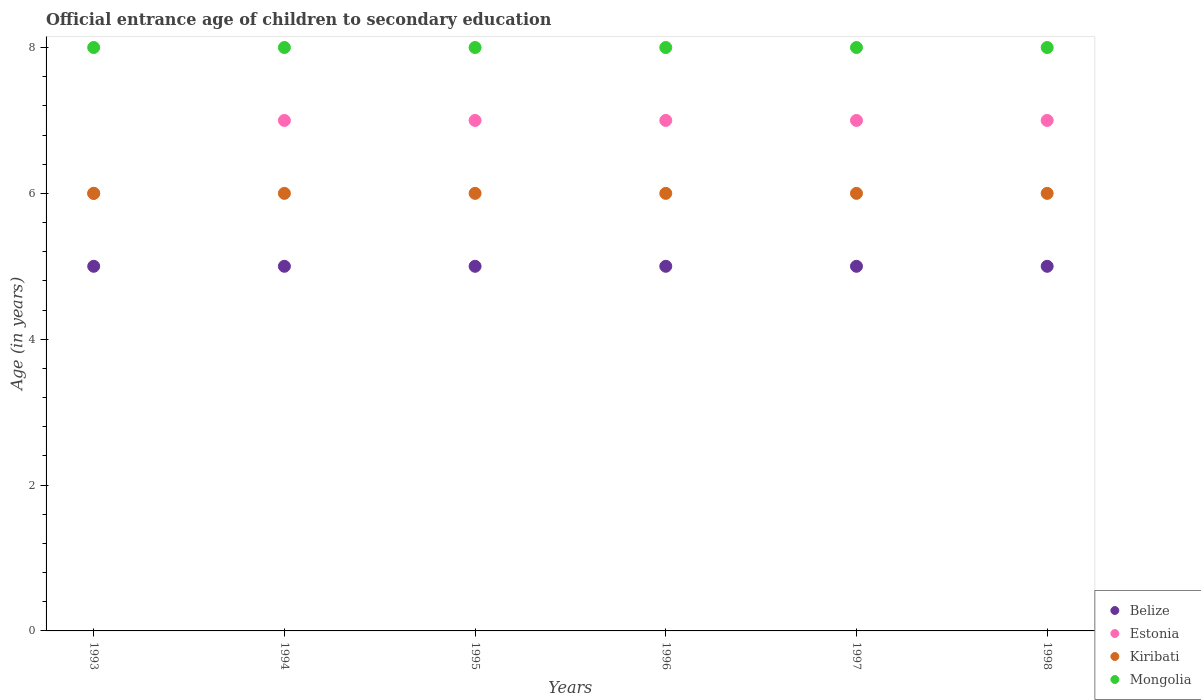Is the number of dotlines equal to the number of legend labels?
Your response must be concise. Yes. What is the secondary school starting age of children in Kiribati in 1997?
Your response must be concise. 6. Across all years, what is the maximum secondary school starting age of children in Belize?
Your answer should be compact. 5. Across all years, what is the minimum secondary school starting age of children in Belize?
Provide a succinct answer. 5. What is the total secondary school starting age of children in Belize in the graph?
Provide a short and direct response. 30. What is the difference between the secondary school starting age of children in Belize in 1996 and that in 1998?
Give a very brief answer. 0. What is the difference between the secondary school starting age of children in Estonia in 1993 and the secondary school starting age of children in Mongolia in 1997?
Ensure brevity in your answer.  -2. What is the average secondary school starting age of children in Estonia per year?
Give a very brief answer. 6.83. In the year 1994, what is the difference between the secondary school starting age of children in Estonia and secondary school starting age of children in Mongolia?
Offer a very short reply. -1. In how many years, is the secondary school starting age of children in Belize greater than 2.8 years?
Give a very brief answer. 6. What is the ratio of the secondary school starting age of children in Estonia in 1993 to that in 1996?
Give a very brief answer. 0.86. What is the difference between the highest and the second highest secondary school starting age of children in Estonia?
Your response must be concise. 0. What is the difference between the highest and the lowest secondary school starting age of children in Mongolia?
Offer a very short reply. 0. Is it the case that in every year, the sum of the secondary school starting age of children in Estonia and secondary school starting age of children in Mongolia  is greater than the secondary school starting age of children in Kiribati?
Ensure brevity in your answer.  Yes. Does the secondary school starting age of children in Mongolia monotonically increase over the years?
Your answer should be very brief. No. Is the secondary school starting age of children in Kiribati strictly less than the secondary school starting age of children in Estonia over the years?
Give a very brief answer. No. How many dotlines are there?
Offer a very short reply. 4. Does the graph contain any zero values?
Your answer should be compact. No. Where does the legend appear in the graph?
Provide a short and direct response. Bottom right. What is the title of the graph?
Your answer should be compact. Official entrance age of children to secondary education. Does "Italy" appear as one of the legend labels in the graph?
Give a very brief answer. No. What is the label or title of the Y-axis?
Make the answer very short. Age (in years). What is the Age (in years) of Belize in 1993?
Make the answer very short. 5. What is the Age (in years) in Belize in 1994?
Keep it short and to the point. 5. What is the Age (in years) of Kiribati in 1994?
Ensure brevity in your answer.  6. What is the Age (in years) in Mongolia in 1995?
Offer a very short reply. 8. What is the Age (in years) of Kiribati in 1996?
Offer a terse response. 6. What is the Age (in years) in Belize in 1997?
Offer a terse response. 5. What is the Age (in years) in Estonia in 1997?
Give a very brief answer. 7. What is the Age (in years) of Belize in 1998?
Your answer should be very brief. 5. Across all years, what is the maximum Age (in years) of Belize?
Provide a succinct answer. 5. Across all years, what is the maximum Age (in years) in Kiribati?
Offer a terse response. 6. Across all years, what is the maximum Age (in years) of Mongolia?
Offer a very short reply. 8. Across all years, what is the minimum Age (in years) of Estonia?
Provide a short and direct response. 6. What is the total Age (in years) in Kiribati in the graph?
Offer a terse response. 36. What is the difference between the Age (in years) of Kiribati in 1993 and that in 1994?
Provide a succinct answer. 0. What is the difference between the Age (in years) of Belize in 1993 and that in 1995?
Give a very brief answer. 0. What is the difference between the Age (in years) in Belize in 1993 and that in 1996?
Provide a short and direct response. 0. What is the difference between the Age (in years) of Kiribati in 1993 and that in 1996?
Keep it short and to the point. 0. What is the difference between the Age (in years) of Belize in 1993 and that in 1997?
Make the answer very short. 0. What is the difference between the Age (in years) of Kiribati in 1993 and that in 1997?
Provide a succinct answer. 0. What is the difference between the Age (in years) in Estonia in 1993 and that in 1998?
Ensure brevity in your answer.  -1. What is the difference between the Age (in years) of Mongolia in 1993 and that in 1998?
Provide a short and direct response. 0. What is the difference between the Age (in years) in Estonia in 1994 and that in 1995?
Your answer should be compact. 0. What is the difference between the Age (in years) in Kiribati in 1994 and that in 1995?
Make the answer very short. 0. What is the difference between the Age (in years) of Estonia in 1994 and that in 1997?
Your answer should be very brief. 0. What is the difference between the Age (in years) in Kiribati in 1994 and that in 1997?
Provide a short and direct response. 0. What is the difference between the Age (in years) of Mongolia in 1994 and that in 1997?
Give a very brief answer. 0. What is the difference between the Age (in years) in Belize in 1994 and that in 1998?
Offer a very short reply. 0. What is the difference between the Age (in years) of Estonia in 1994 and that in 1998?
Provide a succinct answer. 0. What is the difference between the Age (in years) in Kiribati in 1994 and that in 1998?
Your response must be concise. 0. What is the difference between the Age (in years) in Kiribati in 1995 and that in 1996?
Your response must be concise. 0. What is the difference between the Age (in years) in Belize in 1995 and that in 1997?
Give a very brief answer. 0. What is the difference between the Age (in years) in Estonia in 1995 and that in 1997?
Provide a short and direct response. 0. What is the difference between the Age (in years) in Mongolia in 1995 and that in 1997?
Provide a short and direct response. 0. What is the difference between the Age (in years) of Belize in 1995 and that in 1998?
Your response must be concise. 0. What is the difference between the Age (in years) in Estonia in 1995 and that in 1998?
Give a very brief answer. 0. What is the difference between the Age (in years) of Kiribati in 1995 and that in 1998?
Make the answer very short. 0. What is the difference between the Age (in years) of Kiribati in 1996 and that in 1997?
Your answer should be compact. 0. What is the difference between the Age (in years) of Mongolia in 1996 and that in 1997?
Ensure brevity in your answer.  0. What is the difference between the Age (in years) in Belize in 1996 and that in 1998?
Your answer should be compact. 0. What is the difference between the Age (in years) of Estonia in 1996 and that in 1998?
Keep it short and to the point. 0. What is the difference between the Age (in years) in Estonia in 1997 and that in 1998?
Your answer should be very brief. 0. What is the difference between the Age (in years) in Kiribati in 1997 and that in 1998?
Provide a short and direct response. 0. What is the difference between the Age (in years) in Mongolia in 1997 and that in 1998?
Your response must be concise. 0. What is the difference between the Age (in years) in Kiribati in 1993 and the Age (in years) in Mongolia in 1994?
Provide a succinct answer. -2. What is the difference between the Age (in years) of Belize in 1993 and the Age (in years) of Kiribati in 1995?
Your answer should be compact. -1. What is the difference between the Age (in years) in Belize in 1993 and the Age (in years) in Mongolia in 1995?
Offer a terse response. -3. What is the difference between the Age (in years) in Estonia in 1993 and the Age (in years) in Mongolia in 1995?
Your response must be concise. -2. What is the difference between the Age (in years) in Kiribati in 1993 and the Age (in years) in Mongolia in 1995?
Offer a terse response. -2. What is the difference between the Age (in years) of Belize in 1993 and the Age (in years) of Estonia in 1996?
Your response must be concise. -2. What is the difference between the Age (in years) of Belize in 1993 and the Age (in years) of Kiribati in 1996?
Your answer should be compact. -1. What is the difference between the Age (in years) in Estonia in 1993 and the Age (in years) in Mongolia in 1996?
Offer a terse response. -2. What is the difference between the Age (in years) of Belize in 1993 and the Age (in years) of Kiribati in 1997?
Provide a short and direct response. -1. What is the difference between the Age (in years) of Belize in 1993 and the Age (in years) of Kiribati in 1998?
Ensure brevity in your answer.  -1. What is the difference between the Age (in years) in Belize in 1993 and the Age (in years) in Mongolia in 1998?
Provide a succinct answer. -3. What is the difference between the Age (in years) of Estonia in 1993 and the Age (in years) of Kiribati in 1998?
Offer a very short reply. 0. What is the difference between the Age (in years) in Kiribati in 1993 and the Age (in years) in Mongolia in 1998?
Provide a succinct answer. -2. What is the difference between the Age (in years) of Belize in 1994 and the Age (in years) of Mongolia in 1995?
Your answer should be very brief. -3. What is the difference between the Age (in years) in Estonia in 1994 and the Age (in years) in Kiribati in 1995?
Offer a terse response. 1. What is the difference between the Age (in years) of Belize in 1994 and the Age (in years) of Kiribati in 1996?
Provide a short and direct response. -1. What is the difference between the Age (in years) in Belize in 1994 and the Age (in years) in Estonia in 1997?
Offer a terse response. -2. What is the difference between the Age (in years) in Estonia in 1994 and the Age (in years) in Kiribati in 1997?
Give a very brief answer. 1. What is the difference between the Age (in years) in Kiribati in 1994 and the Age (in years) in Mongolia in 1997?
Offer a terse response. -2. What is the difference between the Age (in years) of Belize in 1994 and the Age (in years) of Estonia in 1998?
Keep it short and to the point. -2. What is the difference between the Age (in years) of Belize in 1994 and the Age (in years) of Mongolia in 1998?
Offer a very short reply. -3. What is the difference between the Age (in years) in Estonia in 1994 and the Age (in years) in Kiribati in 1998?
Your response must be concise. 1. What is the difference between the Age (in years) of Kiribati in 1994 and the Age (in years) of Mongolia in 1998?
Your answer should be compact. -2. What is the difference between the Age (in years) of Belize in 1995 and the Age (in years) of Estonia in 1996?
Ensure brevity in your answer.  -2. What is the difference between the Age (in years) in Estonia in 1995 and the Age (in years) in Kiribati in 1996?
Ensure brevity in your answer.  1. What is the difference between the Age (in years) in Kiribati in 1995 and the Age (in years) in Mongolia in 1996?
Your answer should be very brief. -2. What is the difference between the Age (in years) of Estonia in 1995 and the Age (in years) of Mongolia in 1997?
Give a very brief answer. -1. What is the difference between the Age (in years) of Kiribati in 1995 and the Age (in years) of Mongolia in 1997?
Provide a succinct answer. -2. What is the difference between the Age (in years) of Belize in 1995 and the Age (in years) of Estonia in 1998?
Your response must be concise. -2. What is the difference between the Age (in years) of Belize in 1995 and the Age (in years) of Mongolia in 1998?
Make the answer very short. -3. What is the difference between the Age (in years) of Estonia in 1995 and the Age (in years) of Kiribati in 1998?
Make the answer very short. 1. What is the difference between the Age (in years) in Belize in 1996 and the Age (in years) in Estonia in 1997?
Offer a very short reply. -2. What is the difference between the Age (in years) in Estonia in 1996 and the Age (in years) in Kiribati in 1997?
Make the answer very short. 1. What is the difference between the Age (in years) of Estonia in 1996 and the Age (in years) of Mongolia in 1997?
Offer a very short reply. -1. What is the difference between the Age (in years) of Belize in 1996 and the Age (in years) of Estonia in 1998?
Offer a very short reply. -2. What is the difference between the Age (in years) in Belize in 1996 and the Age (in years) in Kiribati in 1998?
Your response must be concise. -1. What is the difference between the Age (in years) in Kiribati in 1996 and the Age (in years) in Mongolia in 1998?
Keep it short and to the point. -2. What is the difference between the Age (in years) of Belize in 1997 and the Age (in years) of Estonia in 1998?
Offer a very short reply. -2. What is the difference between the Age (in years) in Estonia in 1997 and the Age (in years) in Mongolia in 1998?
Your answer should be very brief. -1. What is the average Age (in years) of Estonia per year?
Keep it short and to the point. 6.83. What is the average Age (in years) of Kiribati per year?
Your answer should be compact. 6. What is the average Age (in years) in Mongolia per year?
Your response must be concise. 8. In the year 1993, what is the difference between the Age (in years) of Belize and Age (in years) of Estonia?
Your answer should be compact. -1. In the year 1993, what is the difference between the Age (in years) of Belize and Age (in years) of Kiribati?
Keep it short and to the point. -1. In the year 1993, what is the difference between the Age (in years) in Belize and Age (in years) in Mongolia?
Provide a succinct answer. -3. In the year 1993, what is the difference between the Age (in years) of Kiribati and Age (in years) of Mongolia?
Provide a succinct answer. -2. In the year 1994, what is the difference between the Age (in years) in Belize and Age (in years) in Estonia?
Offer a terse response. -2. In the year 1994, what is the difference between the Age (in years) in Belize and Age (in years) in Mongolia?
Provide a succinct answer. -3. In the year 1994, what is the difference between the Age (in years) of Estonia and Age (in years) of Kiribati?
Your answer should be very brief. 1. In the year 1994, what is the difference between the Age (in years) of Kiribati and Age (in years) of Mongolia?
Your answer should be very brief. -2. In the year 1995, what is the difference between the Age (in years) in Estonia and Age (in years) in Mongolia?
Ensure brevity in your answer.  -1. In the year 1995, what is the difference between the Age (in years) of Kiribati and Age (in years) of Mongolia?
Offer a terse response. -2. In the year 1996, what is the difference between the Age (in years) in Belize and Age (in years) in Kiribati?
Your answer should be very brief. -1. In the year 1996, what is the difference between the Age (in years) in Belize and Age (in years) in Mongolia?
Your response must be concise. -3. In the year 1996, what is the difference between the Age (in years) in Estonia and Age (in years) in Kiribati?
Provide a succinct answer. 1. In the year 1996, what is the difference between the Age (in years) of Estonia and Age (in years) of Mongolia?
Keep it short and to the point. -1. In the year 1996, what is the difference between the Age (in years) in Kiribati and Age (in years) in Mongolia?
Your answer should be very brief. -2. In the year 1997, what is the difference between the Age (in years) in Belize and Age (in years) in Estonia?
Provide a short and direct response. -2. In the year 1997, what is the difference between the Age (in years) of Belize and Age (in years) of Kiribati?
Give a very brief answer. -1. In the year 1997, what is the difference between the Age (in years) in Belize and Age (in years) in Mongolia?
Offer a very short reply. -3. In the year 1997, what is the difference between the Age (in years) of Estonia and Age (in years) of Kiribati?
Your answer should be compact. 1. In the year 1997, what is the difference between the Age (in years) in Estonia and Age (in years) in Mongolia?
Your answer should be compact. -1. In the year 1998, what is the difference between the Age (in years) of Belize and Age (in years) of Estonia?
Give a very brief answer. -2. In the year 1998, what is the difference between the Age (in years) of Belize and Age (in years) of Kiribati?
Your answer should be very brief. -1. In the year 1998, what is the difference between the Age (in years) of Belize and Age (in years) of Mongolia?
Offer a terse response. -3. In the year 1998, what is the difference between the Age (in years) in Estonia and Age (in years) in Kiribati?
Offer a terse response. 1. In the year 1998, what is the difference between the Age (in years) of Kiribati and Age (in years) of Mongolia?
Keep it short and to the point. -2. What is the ratio of the Age (in years) of Belize in 1993 to that in 1995?
Ensure brevity in your answer.  1. What is the ratio of the Age (in years) in Kiribati in 1993 to that in 1995?
Your response must be concise. 1. What is the ratio of the Age (in years) in Mongolia in 1993 to that in 1995?
Your response must be concise. 1. What is the ratio of the Age (in years) in Belize in 1993 to that in 1997?
Offer a terse response. 1. What is the ratio of the Age (in years) in Belize in 1993 to that in 1998?
Your answer should be very brief. 1. What is the ratio of the Age (in years) of Estonia in 1993 to that in 1998?
Give a very brief answer. 0.86. What is the ratio of the Age (in years) in Kiribati in 1993 to that in 1998?
Offer a terse response. 1. What is the ratio of the Age (in years) of Mongolia in 1993 to that in 1998?
Your response must be concise. 1. What is the ratio of the Age (in years) in Kiribati in 1994 to that in 1995?
Your answer should be very brief. 1. What is the ratio of the Age (in years) in Mongolia in 1994 to that in 1995?
Your answer should be compact. 1. What is the ratio of the Age (in years) in Belize in 1994 to that in 1996?
Keep it short and to the point. 1. What is the ratio of the Age (in years) of Estonia in 1994 to that in 1996?
Ensure brevity in your answer.  1. What is the ratio of the Age (in years) of Kiribati in 1994 to that in 1996?
Keep it short and to the point. 1. What is the ratio of the Age (in years) of Estonia in 1994 to that in 1997?
Provide a short and direct response. 1. What is the ratio of the Age (in years) in Mongolia in 1994 to that in 1997?
Make the answer very short. 1. What is the ratio of the Age (in years) in Belize in 1994 to that in 1998?
Your answer should be very brief. 1. What is the ratio of the Age (in years) in Kiribati in 1994 to that in 1998?
Your answer should be compact. 1. What is the ratio of the Age (in years) of Mongolia in 1994 to that in 1998?
Make the answer very short. 1. What is the ratio of the Age (in years) of Estonia in 1995 to that in 1998?
Ensure brevity in your answer.  1. What is the ratio of the Age (in years) of Belize in 1996 to that in 1997?
Your answer should be compact. 1. What is the ratio of the Age (in years) in Kiribati in 1996 to that in 1997?
Give a very brief answer. 1. What is the ratio of the Age (in years) of Mongolia in 1996 to that in 1997?
Provide a succinct answer. 1. What is the ratio of the Age (in years) of Mongolia in 1996 to that in 1998?
Make the answer very short. 1. What is the ratio of the Age (in years) in Belize in 1997 to that in 1998?
Provide a succinct answer. 1. What is the ratio of the Age (in years) of Estonia in 1997 to that in 1998?
Your answer should be compact. 1. What is the ratio of the Age (in years) in Kiribati in 1997 to that in 1998?
Keep it short and to the point. 1. What is the difference between the highest and the second highest Age (in years) of Estonia?
Provide a succinct answer. 0. What is the difference between the highest and the second highest Age (in years) of Kiribati?
Give a very brief answer. 0. What is the difference between the highest and the second highest Age (in years) in Mongolia?
Make the answer very short. 0. What is the difference between the highest and the lowest Age (in years) in Belize?
Give a very brief answer. 0. What is the difference between the highest and the lowest Age (in years) in Mongolia?
Keep it short and to the point. 0. 